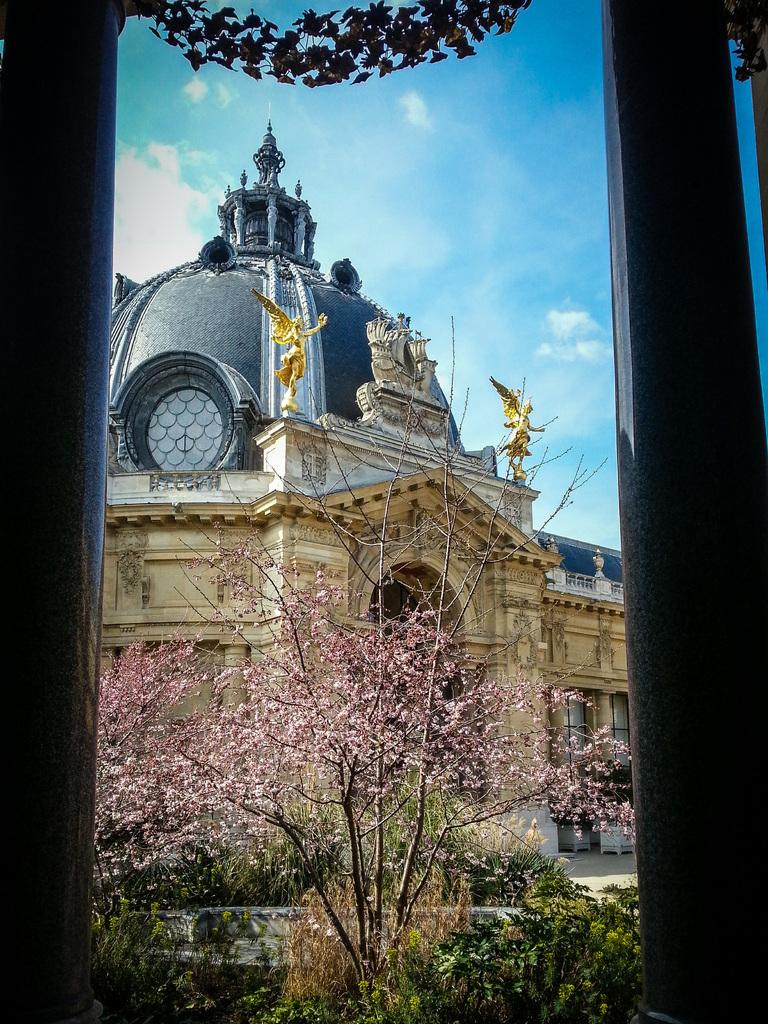What type of natural elements can be seen in the image? There are trees in the image. Can you describe the colors of the trees? The trees have various colors, including green, brown, black, and pink. What type of man-made structures are visible in the background of the image? There are huge buildings in the background of the image. Are there any decorative elements on the buildings? Yes, there are statues on the buildings. What is visible in the sky in the background of the image? The sky is visible in the background of the image. What type of clam is being used for learning in the image? There is no clam present in the image, and therefore no such activity can be observed. 